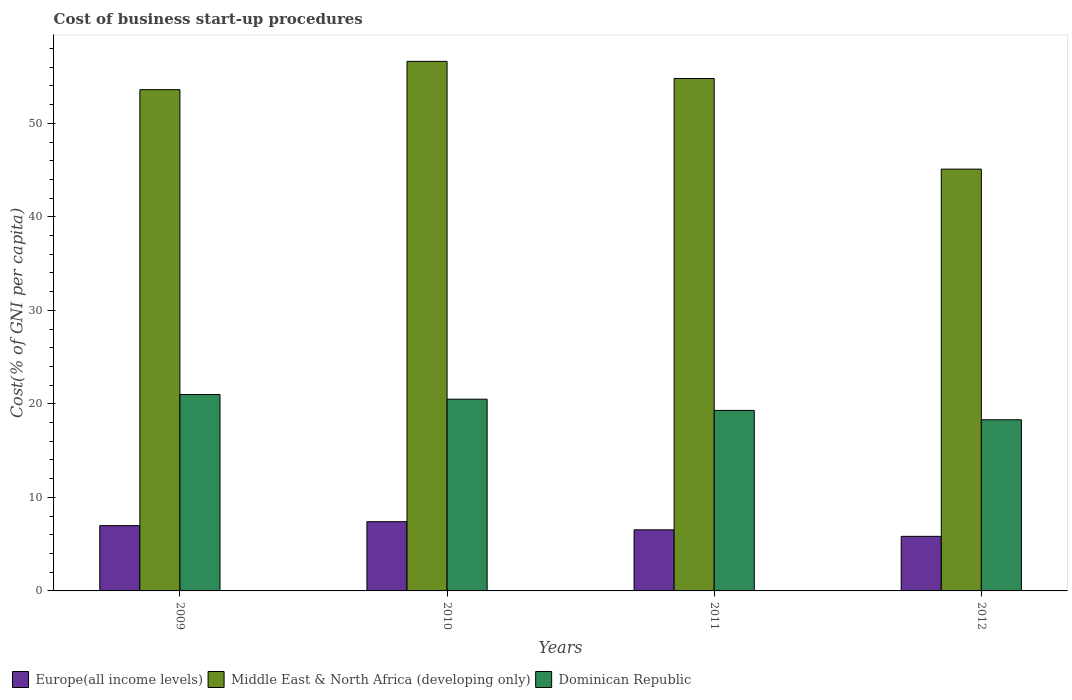How many bars are there on the 1st tick from the left?
Offer a very short reply. 3. How many bars are there on the 1st tick from the right?
Give a very brief answer. 3. What is the label of the 3rd group of bars from the left?
Provide a short and direct response. 2011. In how many cases, is the number of bars for a given year not equal to the number of legend labels?
Give a very brief answer. 0. What is the cost of business start-up procedures in Dominican Republic in 2009?
Provide a succinct answer. 21. Across all years, what is the minimum cost of business start-up procedures in Dominican Republic?
Offer a terse response. 18.3. What is the total cost of business start-up procedures in Europe(all income levels) in the graph?
Your answer should be very brief. 26.75. What is the difference between the cost of business start-up procedures in Europe(all income levels) in 2010 and that in 2011?
Your response must be concise. 0.87. What is the difference between the cost of business start-up procedures in Middle East & North Africa (developing only) in 2011 and the cost of business start-up procedures in Dominican Republic in 2010?
Ensure brevity in your answer.  34.29. What is the average cost of business start-up procedures in Middle East & North Africa (developing only) per year?
Your response must be concise. 52.53. In the year 2009, what is the difference between the cost of business start-up procedures in Middle East & North Africa (developing only) and cost of business start-up procedures in Dominican Republic?
Your answer should be compact. 32.6. What is the ratio of the cost of business start-up procedures in Dominican Republic in 2010 to that in 2011?
Ensure brevity in your answer.  1.06. Is the cost of business start-up procedures in Middle East & North Africa (developing only) in 2009 less than that in 2010?
Your answer should be very brief. Yes. What is the difference between the highest and the second highest cost of business start-up procedures in Middle East & North Africa (developing only)?
Offer a terse response. 1.83. What is the difference between the highest and the lowest cost of business start-up procedures in Middle East & North Africa (developing only)?
Offer a terse response. 11.52. In how many years, is the cost of business start-up procedures in Middle East & North Africa (developing only) greater than the average cost of business start-up procedures in Middle East & North Africa (developing only) taken over all years?
Your answer should be very brief. 3. Is the sum of the cost of business start-up procedures in Europe(all income levels) in 2010 and 2011 greater than the maximum cost of business start-up procedures in Middle East & North Africa (developing only) across all years?
Provide a succinct answer. No. What does the 3rd bar from the left in 2011 represents?
Offer a terse response. Dominican Republic. What does the 1st bar from the right in 2009 represents?
Your answer should be very brief. Dominican Republic. Are all the bars in the graph horizontal?
Keep it short and to the point. No. Are the values on the major ticks of Y-axis written in scientific E-notation?
Provide a short and direct response. No. Does the graph contain grids?
Ensure brevity in your answer.  No. Where does the legend appear in the graph?
Give a very brief answer. Bottom left. What is the title of the graph?
Your answer should be compact. Cost of business start-up procedures. Does "Cabo Verde" appear as one of the legend labels in the graph?
Provide a succinct answer. No. What is the label or title of the Y-axis?
Make the answer very short. Cost(% of GNI per capita). What is the Cost(% of GNI per capita) of Europe(all income levels) in 2009?
Your answer should be compact. 6.98. What is the Cost(% of GNI per capita) of Middle East & North Africa (developing only) in 2009?
Keep it short and to the point. 53.6. What is the Cost(% of GNI per capita) of Dominican Republic in 2009?
Give a very brief answer. 21. What is the Cost(% of GNI per capita) in Europe(all income levels) in 2010?
Your answer should be very brief. 7.4. What is the Cost(% of GNI per capita) of Middle East & North Africa (developing only) in 2010?
Your answer should be very brief. 56.62. What is the Cost(% of GNI per capita) of Europe(all income levels) in 2011?
Make the answer very short. 6.53. What is the Cost(% of GNI per capita) in Middle East & North Africa (developing only) in 2011?
Your answer should be compact. 54.79. What is the Cost(% of GNI per capita) of Dominican Republic in 2011?
Offer a terse response. 19.3. What is the Cost(% of GNI per capita) in Europe(all income levels) in 2012?
Offer a very short reply. 5.84. What is the Cost(% of GNI per capita) of Middle East & North Africa (developing only) in 2012?
Provide a succinct answer. 45.1. Across all years, what is the maximum Cost(% of GNI per capita) of Europe(all income levels)?
Make the answer very short. 7.4. Across all years, what is the maximum Cost(% of GNI per capita) of Middle East & North Africa (developing only)?
Your response must be concise. 56.62. Across all years, what is the minimum Cost(% of GNI per capita) of Europe(all income levels)?
Keep it short and to the point. 5.84. Across all years, what is the minimum Cost(% of GNI per capita) in Middle East & North Africa (developing only)?
Your answer should be very brief. 45.1. What is the total Cost(% of GNI per capita) of Europe(all income levels) in the graph?
Your answer should be compact. 26.75. What is the total Cost(% of GNI per capita) in Middle East & North Africa (developing only) in the graph?
Your answer should be very brief. 210.12. What is the total Cost(% of GNI per capita) of Dominican Republic in the graph?
Ensure brevity in your answer.  79.1. What is the difference between the Cost(% of GNI per capita) of Europe(all income levels) in 2009 and that in 2010?
Make the answer very short. -0.42. What is the difference between the Cost(% of GNI per capita) of Middle East & North Africa (developing only) in 2009 and that in 2010?
Your answer should be compact. -3.02. What is the difference between the Cost(% of GNI per capita) of Dominican Republic in 2009 and that in 2010?
Provide a short and direct response. 0.5. What is the difference between the Cost(% of GNI per capita) in Europe(all income levels) in 2009 and that in 2011?
Ensure brevity in your answer.  0.45. What is the difference between the Cost(% of GNI per capita) in Middle East & North Africa (developing only) in 2009 and that in 2011?
Provide a short and direct response. -1.19. What is the difference between the Cost(% of GNI per capita) in Dominican Republic in 2009 and that in 2011?
Provide a short and direct response. 1.7. What is the difference between the Cost(% of GNI per capita) in Europe(all income levels) in 2009 and that in 2012?
Give a very brief answer. 1.15. What is the difference between the Cost(% of GNI per capita) in Dominican Republic in 2009 and that in 2012?
Offer a very short reply. 2.7. What is the difference between the Cost(% of GNI per capita) in Europe(all income levels) in 2010 and that in 2011?
Your response must be concise. 0.87. What is the difference between the Cost(% of GNI per capita) in Middle East & North Africa (developing only) in 2010 and that in 2011?
Make the answer very short. 1.83. What is the difference between the Cost(% of GNI per capita) of Europe(all income levels) in 2010 and that in 2012?
Your answer should be very brief. 1.57. What is the difference between the Cost(% of GNI per capita) of Middle East & North Africa (developing only) in 2010 and that in 2012?
Offer a very short reply. 11.53. What is the difference between the Cost(% of GNI per capita) of Europe(all income levels) in 2011 and that in 2012?
Your answer should be very brief. 0.7. What is the difference between the Cost(% of GNI per capita) in Middle East & North Africa (developing only) in 2011 and that in 2012?
Offer a very short reply. 9.69. What is the difference between the Cost(% of GNI per capita) in Dominican Republic in 2011 and that in 2012?
Offer a very short reply. 1. What is the difference between the Cost(% of GNI per capita) of Europe(all income levels) in 2009 and the Cost(% of GNI per capita) of Middle East & North Africa (developing only) in 2010?
Your answer should be compact. -49.64. What is the difference between the Cost(% of GNI per capita) of Europe(all income levels) in 2009 and the Cost(% of GNI per capita) of Dominican Republic in 2010?
Provide a short and direct response. -13.52. What is the difference between the Cost(% of GNI per capita) of Middle East & North Africa (developing only) in 2009 and the Cost(% of GNI per capita) of Dominican Republic in 2010?
Keep it short and to the point. 33.1. What is the difference between the Cost(% of GNI per capita) in Europe(all income levels) in 2009 and the Cost(% of GNI per capita) in Middle East & North Africa (developing only) in 2011?
Ensure brevity in your answer.  -47.81. What is the difference between the Cost(% of GNI per capita) in Europe(all income levels) in 2009 and the Cost(% of GNI per capita) in Dominican Republic in 2011?
Give a very brief answer. -12.32. What is the difference between the Cost(% of GNI per capita) of Middle East & North Africa (developing only) in 2009 and the Cost(% of GNI per capita) of Dominican Republic in 2011?
Offer a very short reply. 34.3. What is the difference between the Cost(% of GNI per capita) of Europe(all income levels) in 2009 and the Cost(% of GNI per capita) of Middle East & North Africa (developing only) in 2012?
Keep it short and to the point. -38.12. What is the difference between the Cost(% of GNI per capita) of Europe(all income levels) in 2009 and the Cost(% of GNI per capita) of Dominican Republic in 2012?
Give a very brief answer. -11.32. What is the difference between the Cost(% of GNI per capita) in Middle East & North Africa (developing only) in 2009 and the Cost(% of GNI per capita) in Dominican Republic in 2012?
Offer a very short reply. 35.3. What is the difference between the Cost(% of GNI per capita) of Europe(all income levels) in 2010 and the Cost(% of GNI per capita) of Middle East & North Africa (developing only) in 2011?
Keep it short and to the point. -47.39. What is the difference between the Cost(% of GNI per capita) of Europe(all income levels) in 2010 and the Cost(% of GNI per capita) of Dominican Republic in 2011?
Your response must be concise. -11.9. What is the difference between the Cost(% of GNI per capita) of Middle East & North Africa (developing only) in 2010 and the Cost(% of GNI per capita) of Dominican Republic in 2011?
Make the answer very short. 37.33. What is the difference between the Cost(% of GNI per capita) in Europe(all income levels) in 2010 and the Cost(% of GNI per capita) in Middle East & North Africa (developing only) in 2012?
Offer a terse response. -37.7. What is the difference between the Cost(% of GNI per capita) of Europe(all income levels) in 2010 and the Cost(% of GNI per capita) of Dominican Republic in 2012?
Offer a terse response. -10.9. What is the difference between the Cost(% of GNI per capita) of Middle East & North Africa (developing only) in 2010 and the Cost(% of GNI per capita) of Dominican Republic in 2012?
Make the answer very short. 38.33. What is the difference between the Cost(% of GNI per capita) of Europe(all income levels) in 2011 and the Cost(% of GNI per capita) of Middle East & North Africa (developing only) in 2012?
Offer a terse response. -38.57. What is the difference between the Cost(% of GNI per capita) in Europe(all income levels) in 2011 and the Cost(% of GNI per capita) in Dominican Republic in 2012?
Provide a short and direct response. -11.77. What is the difference between the Cost(% of GNI per capita) of Middle East & North Africa (developing only) in 2011 and the Cost(% of GNI per capita) of Dominican Republic in 2012?
Make the answer very short. 36.49. What is the average Cost(% of GNI per capita) in Europe(all income levels) per year?
Ensure brevity in your answer.  6.69. What is the average Cost(% of GNI per capita) of Middle East & North Africa (developing only) per year?
Give a very brief answer. 52.53. What is the average Cost(% of GNI per capita) of Dominican Republic per year?
Your answer should be compact. 19.77. In the year 2009, what is the difference between the Cost(% of GNI per capita) in Europe(all income levels) and Cost(% of GNI per capita) in Middle East & North Africa (developing only)?
Your answer should be compact. -46.62. In the year 2009, what is the difference between the Cost(% of GNI per capita) of Europe(all income levels) and Cost(% of GNI per capita) of Dominican Republic?
Give a very brief answer. -14.02. In the year 2009, what is the difference between the Cost(% of GNI per capita) in Middle East & North Africa (developing only) and Cost(% of GNI per capita) in Dominican Republic?
Ensure brevity in your answer.  32.6. In the year 2010, what is the difference between the Cost(% of GNI per capita) of Europe(all income levels) and Cost(% of GNI per capita) of Middle East & North Africa (developing only)?
Give a very brief answer. -49.22. In the year 2010, what is the difference between the Cost(% of GNI per capita) in Europe(all income levels) and Cost(% of GNI per capita) in Dominican Republic?
Your answer should be very brief. -13.1. In the year 2010, what is the difference between the Cost(% of GNI per capita) in Middle East & North Africa (developing only) and Cost(% of GNI per capita) in Dominican Republic?
Provide a succinct answer. 36.12. In the year 2011, what is the difference between the Cost(% of GNI per capita) of Europe(all income levels) and Cost(% of GNI per capita) of Middle East & North Africa (developing only)?
Ensure brevity in your answer.  -48.26. In the year 2011, what is the difference between the Cost(% of GNI per capita) of Europe(all income levels) and Cost(% of GNI per capita) of Dominican Republic?
Offer a very short reply. -12.77. In the year 2011, what is the difference between the Cost(% of GNI per capita) of Middle East & North Africa (developing only) and Cost(% of GNI per capita) of Dominican Republic?
Your answer should be compact. 35.49. In the year 2012, what is the difference between the Cost(% of GNI per capita) in Europe(all income levels) and Cost(% of GNI per capita) in Middle East & North Africa (developing only)?
Provide a short and direct response. -39.26. In the year 2012, what is the difference between the Cost(% of GNI per capita) of Europe(all income levels) and Cost(% of GNI per capita) of Dominican Republic?
Provide a short and direct response. -12.46. In the year 2012, what is the difference between the Cost(% of GNI per capita) in Middle East & North Africa (developing only) and Cost(% of GNI per capita) in Dominican Republic?
Your answer should be compact. 26.8. What is the ratio of the Cost(% of GNI per capita) in Europe(all income levels) in 2009 to that in 2010?
Offer a terse response. 0.94. What is the ratio of the Cost(% of GNI per capita) in Middle East & North Africa (developing only) in 2009 to that in 2010?
Offer a terse response. 0.95. What is the ratio of the Cost(% of GNI per capita) in Dominican Republic in 2009 to that in 2010?
Your answer should be compact. 1.02. What is the ratio of the Cost(% of GNI per capita) of Europe(all income levels) in 2009 to that in 2011?
Provide a short and direct response. 1.07. What is the ratio of the Cost(% of GNI per capita) in Middle East & North Africa (developing only) in 2009 to that in 2011?
Provide a succinct answer. 0.98. What is the ratio of the Cost(% of GNI per capita) in Dominican Republic in 2009 to that in 2011?
Offer a very short reply. 1.09. What is the ratio of the Cost(% of GNI per capita) in Europe(all income levels) in 2009 to that in 2012?
Ensure brevity in your answer.  1.2. What is the ratio of the Cost(% of GNI per capita) in Middle East & North Africa (developing only) in 2009 to that in 2012?
Offer a terse response. 1.19. What is the ratio of the Cost(% of GNI per capita) of Dominican Republic in 2009 to that in 2012?
Make the answer very short. 1.15. What is the ratio of the Cost(% of GNI per capita) of Europe(all income levels) in 2010 to that in 2011?
Your answer should be very brief. 1.13. What is the ratio of the Cost(% of GNI per capita) in Middle East & North Africa (developing only) in 2010 to that in 2011?
Provide a short and direct response. 1.03. What is the ratio of the Cost(% of GNI per capita) in Dominican Republic in 2010 to that in 2011?
Your answer should be very brief. 1.06. What is the ratio of the Cost(% of GNI per capita) in Europe(all income levels) in 2010 to that in 2012?
Provide a succinct answer. 1.27. What is the ratio of the Cost(% of GNI per capita) of Middle East & North Africa (developing only) in 2010 to that in 2012?
Give a very brief answer. 1.26. What is the ratio of the Cost(% of GNI per capita) in Dominican Republic in 2010 to that in 2012?
Offer a very short reply. 1.12. What is the ratio of the Cost(% of GNI per capita) in Europe(all income levels) in 2011 to that in 2012?
Keep it short and to the point. 1.12. What is the ratio of the Cost(% of GNI per capita) of Middle East & North Africa (developing only) in 2011 to that in 2012?
Your answer should be very brief. 1.21. What is the ratio of the Cost(% of GNI per capita) of Dominican Republic in 2011 to that in 2012?
Your answer should be compact. 1.05. What is the difference between the highest and the second highest Cost(% of GNI per capita) of Europe(all income levels)?
Provide a short and direct response. 0.42. What is the difference between the highest and the second highest Cost(% of GNI per capita) of Middle East & North Africa (developing only)?
Keep it short and to the point. 1.83. What is the difference between the highest and the lowest Cost(% of GNI per capita) in Europe(all income levels)?
Your answer should be very brief. 1.57. What is the difference between the highest and the lowest Cost(% of GNI per capita) of Middle East & North Africa (developing only)?
Provide a short and direct response. 11.53. What is the difference between the highest and the lowest Cost(% of GNI per capita) in Dominican Republic?
Give a very brief answer. 2.7. 